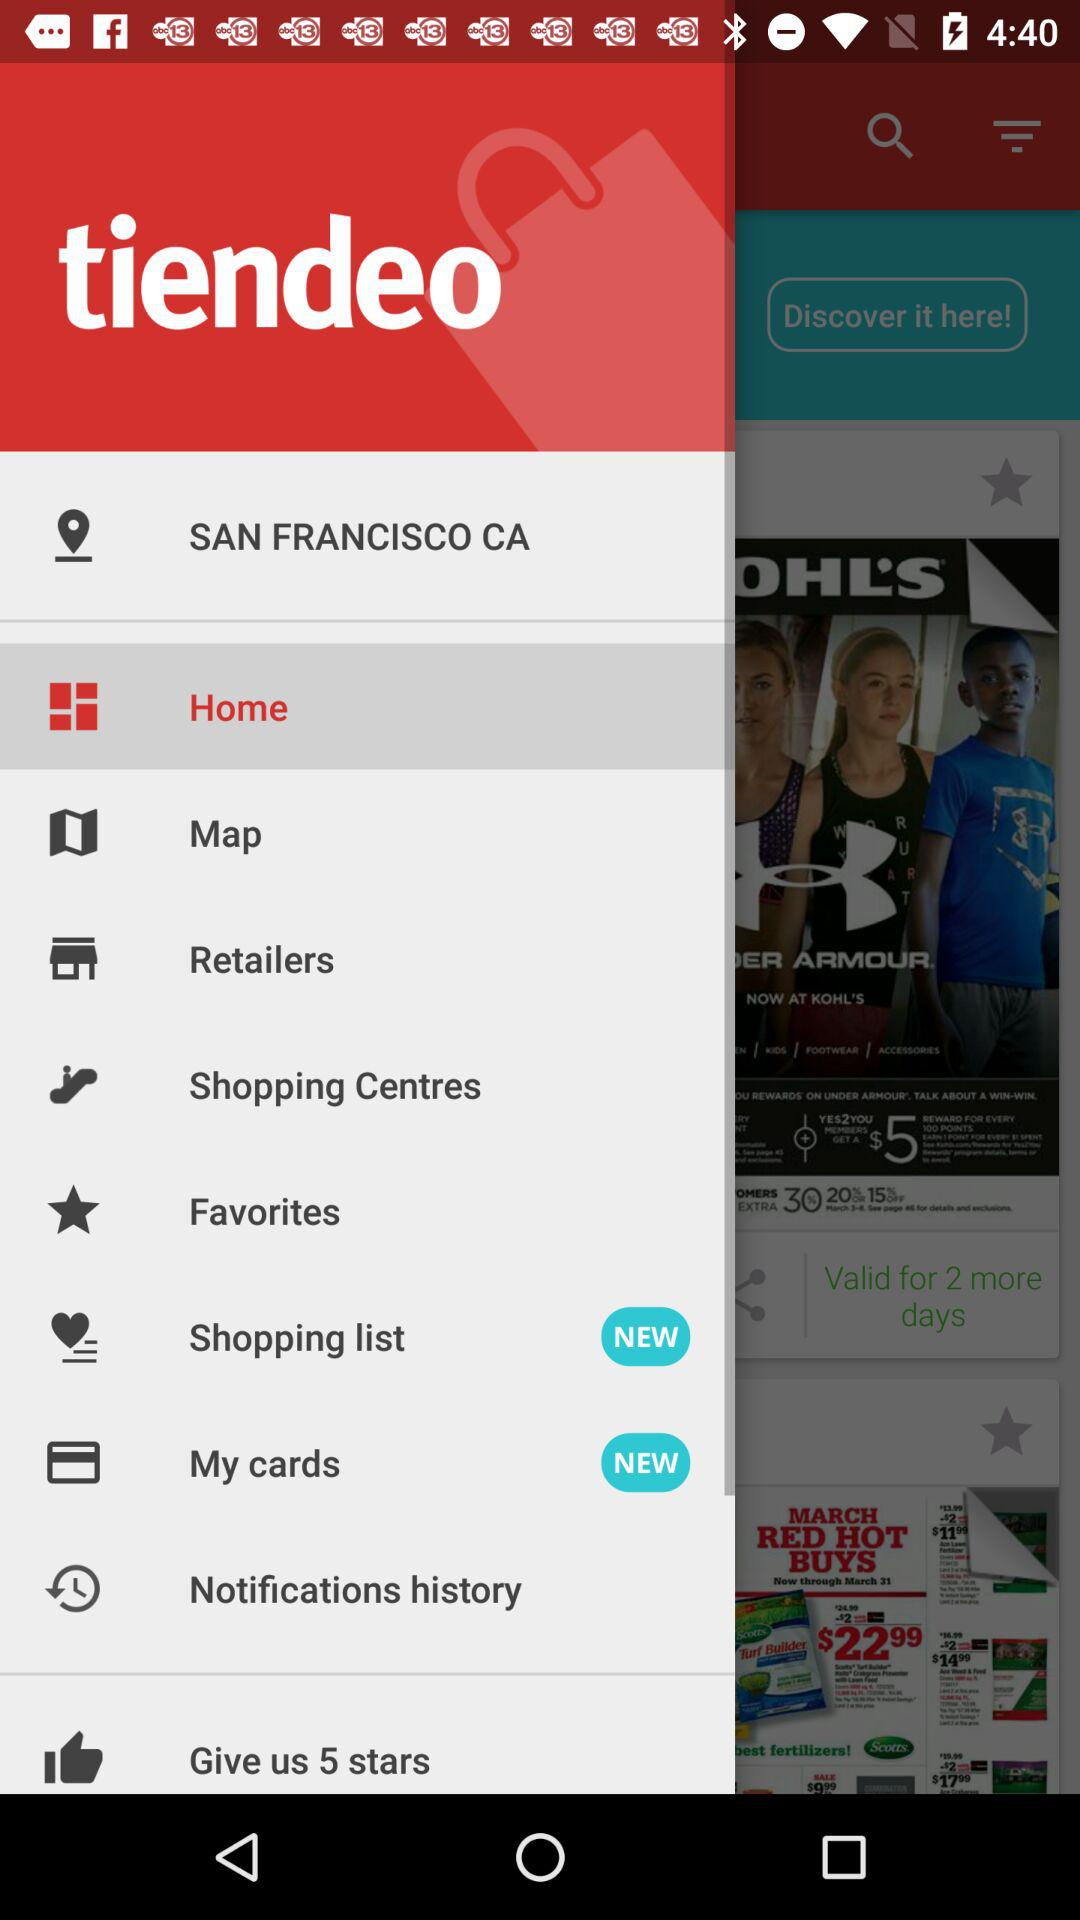What is the name of the application? The name of the application is "tiendeo". 